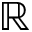<formula> <loc_0><loc_0><loc_500><loc_500>\mathbb { R }</formula> 